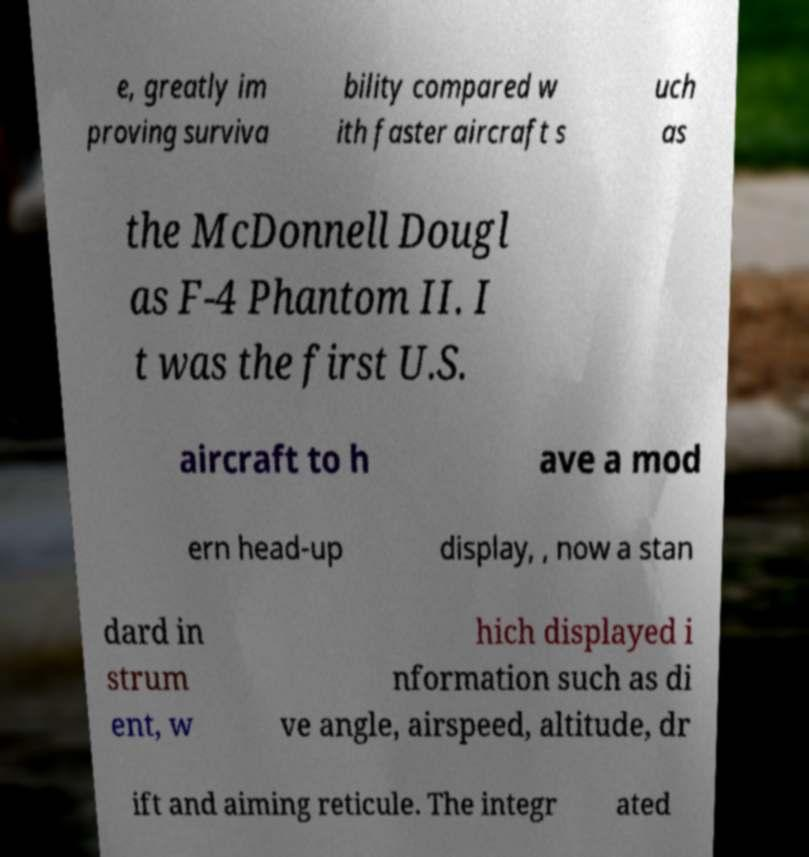What messages or text are displayed in this image? I need them in a readable, typed format. e, greatly im proving surviva bility compared w ith faster aircraft s uch as the McDonnell Dougl as F-4 Phantom II. I t was the first U.S. aircraft to h ave a mod ern head-up display, , now a stan dard in strum ent, w hich displayed i nformation such as di ve angle, airspeed, altitude, dr ift and aiming reticule. The integr ated 